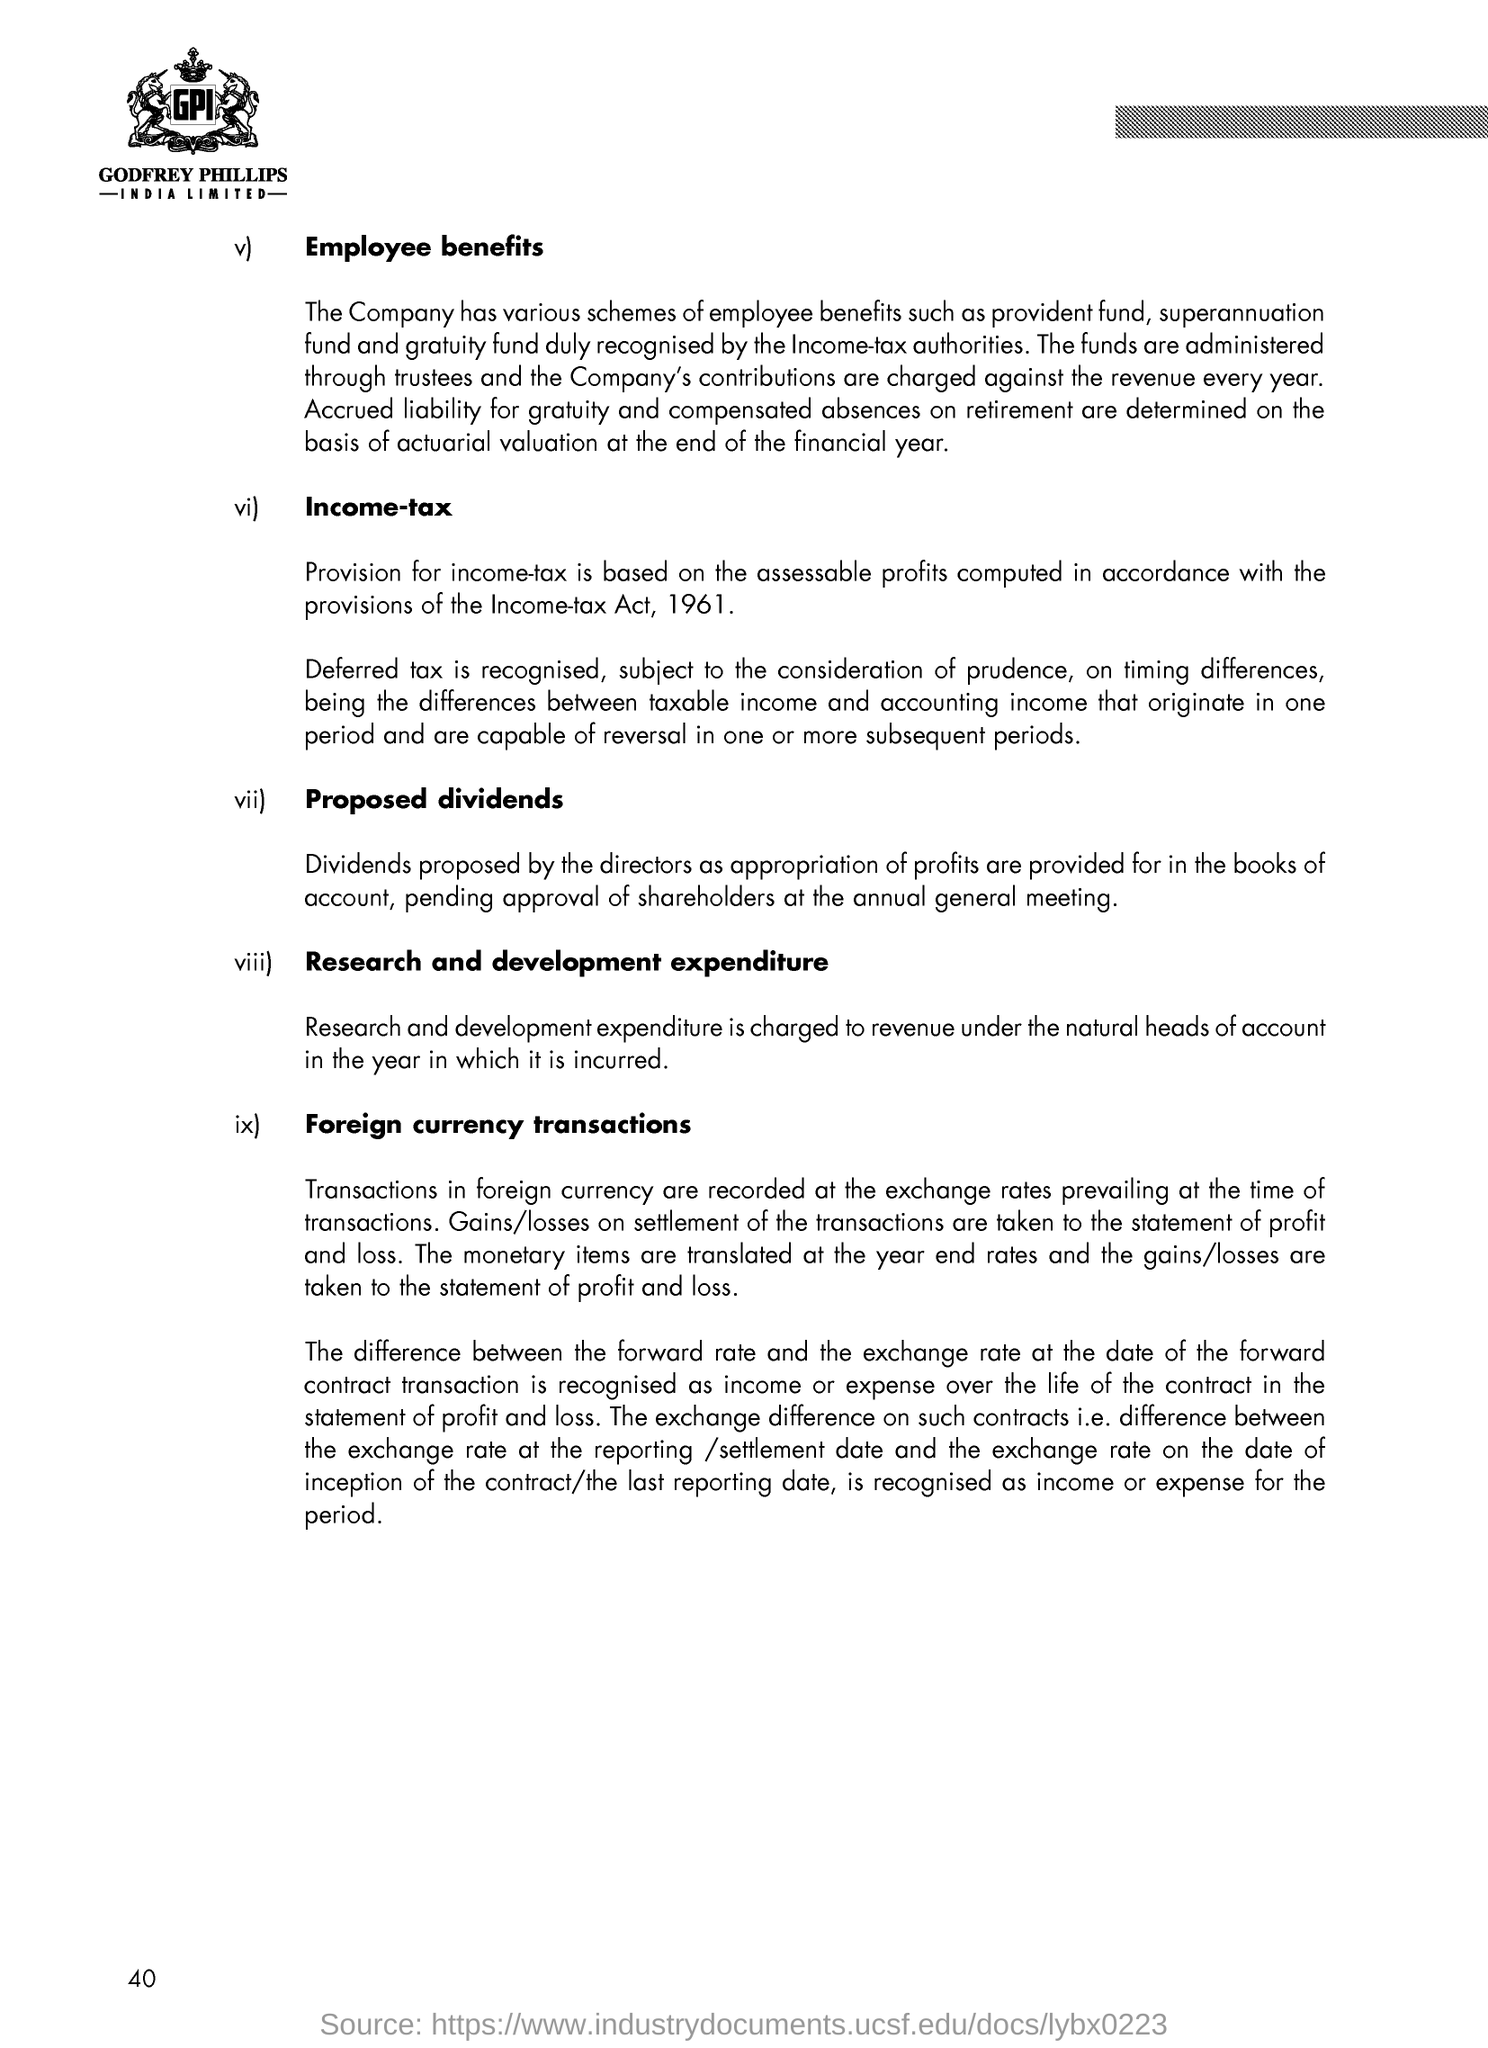Can you list the type of employee benefits mentioned in the document? The document lists several employee benefits provided by the company. These include schemes like provident fund, superannuation fund, and gratuity fund, which are recognized by the Income-tax authorities. It also mentions that the company's contributions to these funds are charged against revenue each year, and that accrued liability for gratuity and compensated absences upon retirement is determined based on actuarial valuation at the end of the financial year. 